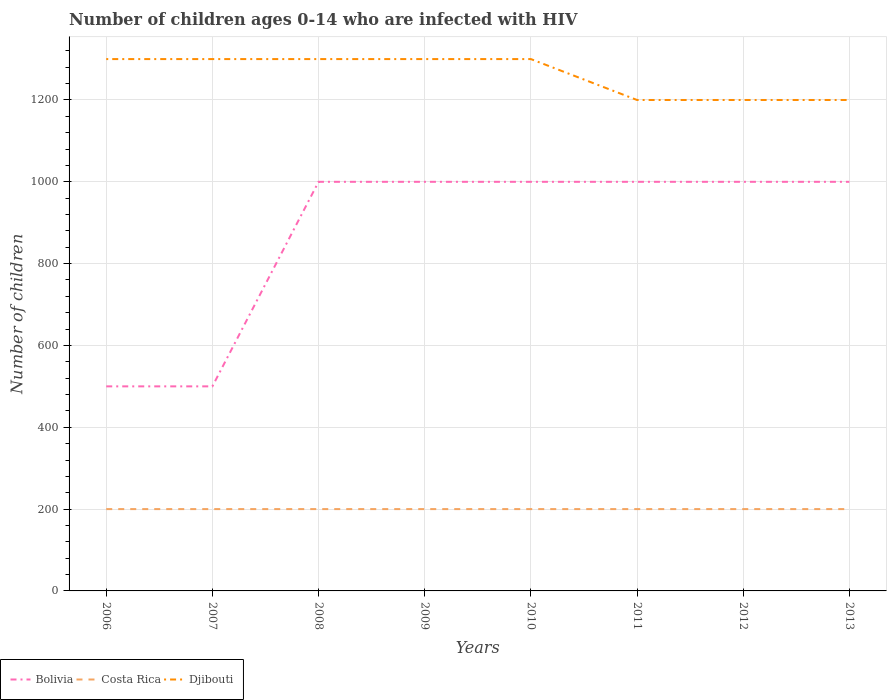How many different coloured lines are there?
Provide a short and direct response. 3. Does the line corresponding to Djibouti intersect with the line corresponding to Costa Rica?
Ensure brevity in your answer.  No. Is the number of lines equal to the number of legend labels?
Offer a very short reply. Yes. Across all years, what is the maximum number of HIV infected children in Bolivia?
Provide a succinct answer. 500. What is the total number of HIV infected children in Bolivia in the graph?
Make the answer very short. 0. Is the number of HIV infected children in Djibouti strictly greater than the number of HIV infected children in Costa Rica over the years?
Give a very brief answer. No. What is the difference between two consecutive major ticks on the Y-axis?
Make the answer very short. 200. Are the values on the major ticks of Y-axis written in scientific E-notation?
Your answer should be compact. No. Where does the legend appear in the graph?
Give a very brief answer. Bottom left. How many legend labels are there?
Your answer should be very brief. 3. What is the title of the graph?
Offer a terse response. Number of children ages 0-14 who are infected with HIV. Does "Timor-Leste" appear as one of the legend labels in the graph?
Ensure brevity in your answer.  No. What is the label or title of the X-axis?
Your answer should be very brief. Years. What is the label or title of the Y-axis?
Offer a terse response. Number of children. What is the Number of children in Bolivia in 2006?
Keep it short and to the point. 500. What is the Number of children of Costa Rica in 2006?
Ensure brevity in your answer.  200. What is the Number of children of Djibouti in 2006?
Offer a very short reply. 1300. What is the Number of children in Costa Rica in 2007?
Keep it short and to the point. 200. What is the Number of children in Djibouti in 2007?
Keep it short and to the point. 1300. What is the Number of children of Bolivia in 2008?
Make the answer very short. 1000. What is the Number of children in Costa Rica in 2008?
Provide a short and direct response. 200. What is the Number of children in Djibouti in 2008?
Provide a succinct answer. 1300. What is the Number of children of Bolivia in 2009?
Offer a very short reply. 1000. What is the Number of children of Djibouti in 2009?
Your answer should be compact. 1300. What is the Number of children of Djibouti in 2010?
Provide a succinct answer. 1300. What is the Number of children in Bolivia in 2011?
Give a very brief answer. 1000. What is the Number of children of Costa Rica in 2011?
Your answer should be very brief. 200. What is the Number of children of Djibouti in 2011?
Offer a terse response. 1200. What is the Number of children in Bolivia in 2012?
Offer a terse response. 1000. What is the Number of children in Djibouti in 2012?
Your answer should be very brief. 1200. What is the Number of children in Bolivia in 2013?
Make the answer very short. 1000. What is the Number of children in Costa Rica in 2013?
Ensure brevity in your answer.  200. What is the Number of children of Djibouti in 2013?
Offer a terse response. 1200. Across all years, what is the maximum Number of children in Bolivia?
Keep it short and to the point. 1000. Across all years, what is the maximum Number of children in Djibouti?
Offer a very short reply. 1300. Across all years, what is the minimum Number of children in Bolivia?
Provide a succinct answer. 500. Across all years, what is the minimum Number of children of Djibouti?
Provide a short and direct response. 1200. What is the total Number of children in Bolivia in the graph?
Keep it short and to the point. 7000. What is the total Number of children of Costa Rica in the graph?
Your response must be concise. 1600. What is the total Number of children of Djibouti in the graph?
Your answer should be compact. 1.01e+04. What is the difference between the Number of children in Bolivia in 2006 and that in 2008?
Keep it short and to the point. -500. What is the difference between the Number of children of Djibouti in 2006 and that in 2008?
Provide a short and direct response. 0. What is the difference between the Number of children of Bolivia in 2006 and that in 2009?
Provide a succinct answer. -500. What is the difference between the Number of children of Bolivia in 2006 and that in 2010?
Give a very brief answer. -500. What is the difference between the Number of children of Djibouti in 2006 and that in 2010?
Give a very brief answer. 0. What is the difference between the Number of children of Bolivia in 2006 and that in 2011?
Offer a very short reply. -500. What is the difference between the Number of children of Djibouti in 2006 and that in 2011?
Your answer should be compact. 100. What is the difference between the Number of children of Bolivia in 2006 and that in 2012?
Provide a succinct answer. -500. What is the difference between the Number of children of Djibouti in 2006 and that in 2012?
Offer a very short reply. 100. What is the difference between the Number of children in Bolivia in 2006 and that in 2013?
Provide a succinct answer. -500. What is the difference between the Number of children of Djibouti in 2006 and that in 2013?
Keep it short and to the point. 100. What is the difference between the Number of children in Bolivia in 2007 and that in 2008?
Make the answer very short. -500. What is the difference between the Number of children in Costa Rica in 2007 and that in 2008?
Give a very brief answer. 0. What is the difference between the Number of children in Bolivia in 2007 and that in 2009?
Offer a terse response. -500. What is the difference between the Number of children of Djibouti in 2007 and that in 2009?
Provide a short and direct response. 0. What is the difference between the Number of children of Bolivia in 2007 and that in 2010?
Your answer should be compact. -500. What is the difference between the Number of children in Costa Rica in 2007 and that in 2010?
Your response must be concise. 0. What is the difference between the Number of children of Bolivia in 2007 and that in 2011?
Give a very brief answer. -500. What is the difference between the Number of children in Bolivia in 2007 and that in 2012?
Offer a very short reply. -500. What is the difference between the Number of children of Costa Rica in 2007 and that in 2012?
Provide a succinct answer. 0. What is the difference between the Number of children in Djibouti in 2007 and that in 2012?
Give a very brief answer. 100. What is the difference between the Number of children in Bolivia in 2007 and that in 2013?
Ensure brevity in your answer.  -500. What is the difference between the Number of children in Bolivia in 2008 and that in 2009?
Give a very brief answer. 0. What is the difference between the Number of children of Costa Rica in 2008 and that in 2009?
Provide a short and direct response. 0. What is the difference between the Number of children in Djibouti in 2008 and that in 2009?
Offer a very short reply. 0. What is the difference between the Number of children in Bolivia in 2008 and that in 2010?
Provide a succinct answer. 0. What is the difference between the Number of children of Costa Rica in 2008 and that in 2010?
Offer a terse response. 0. What is the difference between the Number of children in Djibouti in 2008 and that in 2010?
Ensure brevity in your answer.  0. What is the difference between the Number of children in Bolivia in 2008 and that in 2011?
Provide a short and direct response. 0. What is the difference between the Number of children in Costa Rica in 2008 and that in 2011?
Offer a terse response. 0. What is the difference between the Number of children in Djibouti in 2008 and that in 2011?
Ensure brevity in your answer.  100. What is the difference between the Number of children in Bolivia in 2008 and that in 2012?
Your answer should be very brief. 0. What is the difference between the Number of children in Djibouti in 2008 and that in 2013?
Offer a very short reply. 100. What is the difference between the Number of children in Bolivia in 2009 and that in 2011?
Provide a succinct answer. 0. What is the difference between the Number of children of Costa Rica in 2009 and that in 2011?
Provide a succinct answer. 0. What is the difference between the Number of children in Djibouti in 2009 and that in 2011?
Make the answer very short. 100. What is the difference between the Number of children of Bolivia in 2009 and that in 2012?
Your answer should be compact. 0. What is the difference between the Number of children of Djibouti in 2009 and that in 2013?
Ensure brevity in your answer.  100. What is the difference between the Number of children of Bolivia in 2010 and that in 2011?
Give a very brief answer. 0. What is the difference between the Number of children in Costa Rica in 2010 and that in 2011?
Your answer should be compact. 0. What is the difference between the Number of children in Djibouti in 2010 and that in 2012?
Offer a terse response. 100. What is the difference between the Number of children in Bolivia in 2010 and that in 2013?
Provide a succinct answer. 0. What is the difference between the Number of children in Costa Rica in 2010 and that in 2013?
Give a very brief answer. 0. What is the difference between the Number of children in Bolivia in 2011 and that in 2012?
Ensure brevity in your answer.  0. What is the difference between the Number of children in Djibouti in 2011 and that in 2012?
Your response must be concise. 0. What is the difference between the Number of children in Bolivia in 2011 and that in 2013?
Offer a very short reply. 0. What is the difference between the Number of children of Costa Rica in 2012 and that in 2013?
Your answer should be very brief. 0. What is the difference between the Number of children in Bolivia in 2006 and the Number of children in Costa Rica in 2007?
Your answer should be compact. 300. What is the difference between the Number of children in Bolivia in 2006 and the Number of children in Djibouti in 2007?
Give a very brief answer. -800. What is the difference between the Number of children in Costa Rica in 2006 and the Number of children in Djibouti in 2007?
Provide a succinct answer. -1100. What is the difference between the Number of children in Bolivia in 2006 and the Number of children in Costa Rica in 2008?
Ensure brevity in your answer.  300. What is the difference between the Number of children in Bolivia in 2006 and the Number of children in Djibouti in 2008?
Your response must be concise. -800. What is the difference between the Number of children in Costa Rica in 2006 and the Number of children in Djibouti in 2008?
Offer a very short reply. -1100. What is the difference between the Number of children in Bolivia in 2006 and the Number of children in Costa Rica in 2009?
Your response must be concise. 300. What is the difference between the Number of children in Bolivia in 2006 and the Number of children in Djibouti in 2009?
Give a very brief answer. -800. What is the difference between the Number of children in Costa Rica in 2006 and the Number of children in Djibouti in 2009?
Make the answer very short. -1100. What is the difference between the Number of children of Bolivia in 2006 and the Number of children of Costa Rica in 2010?
Your answer should be very brief. 300. What is the difference between the Number of children in Bolivia in 2006 and the Number of children in Djibouti in 2010?
Provide a succinct answer. -800. What is the difference between the Number of children in Costa Rica in 2006 and the Number of children in Djibouti in 2010?
Your response must be concise. -1100. What is the difference between the Number of children of Bolivia in 2006 and the Number of children of Costa Rica in 2011?
Offer a very short reply. 300. What is the difference between the Number of children in Bolivia in 2006 and the Number of children in Djibouti in 2011?
Your answer should be compact. -700. What is the difference between the Number of children in Costa Rica in 2006 and the Number of children in Djibouti in 2011?
Provide a short and direct response. -1000. What is the difference between the Number of children of Bolivia in 2006 and the Number of children of Costa Rica in 2012?
Offer a very short reply. 300. What is the difference between the Number of children in Bolivia in 2006 and the Number of children in Djibouti in 2012?
Make the answer very short. -700. What is the difference between the Number of children of Costa Rica in 2006 and the Number of children of Djibouti in 2012?
Ensure brevity in your answer.  -1000. What is the difference between the Number of children of Bolivia in 2006 and the Number of children of Costa Rica in 2013?
Your answer should be very brief. 300. What is the difference between the Number of children of Bolivia in 2006 and the Number of children of Djibouti in 2013?
Provide a short and direct response. -700. What is the difference between the Number of children in Costa Rica in 2006 and the Number of children in Djibouti in 2013?
Your answer should be compact. -1000. What is the difference between the Number of children of Bolivia in 2007 and the Number of children of Costa Rica in 2008?
Offer a terse response. 300. What is the difference between the Number of children in Bolivia in 2007 and the Number of children in Djibouti in 2008?
Your response must be concise. -800. What is the difference between the Number of children in Costa Rica in 2007 and the Number of children in Djibouti in 2008?
Give a very brief answer. -1100. What is the difference between the Number of children of Bolivia in 2007 and the Number of children of Costa Rica in 2009?
Ensure brevity in your answer.  300. What is the difference between the Number of children of Bolivia in 2007 and the Number of children of Djibouti in 2009?
Offer a terse response. -800. What is the difference between the Number of children in Costa Rica in 2007 and the Number of children in Djibouti in 2009?
Your response must be concise. -1100. What is the difference between the Number of children of Bolivia in 2007 and the Number of children of Costa Rica in 2010?
Make the answer very short. 300. What is the difference between the Number of children in Bolivia in 2007 and the Number of children in Djibouti in 2010?
Provide a succinct answer. -800. What is the difference between the Number of children of Costa Rica in 2007 and the Number of children of Djibouti in 2010?
Your response must be concise. -1100. What is the difference between the Number of children of Bolivia in 2007 and the Number of children of Costa Rica in 2011?
Provide a succinct answer. 300. What is the difference between the Number of children in Bolivia in 2007 and the Number of children in Djibouti in 2011?
Provide a short and direct response. -700. What is the difference between the Number of children in Costa Rica in 2007 and the Number of children in Djibouti in 2011?
Keep it short and to the point. -1000. What is the difference between the Number of children in Bolivia in 2007 and the Number of children in Costa Rica in 2012?
Make the answer very short. 300. What is the difference between the Number of children in Bolivia in 2007 and the Number of children in Djibouti in 2012?
Keep it short and to the point. -700. What is the difference between the Number of children in Costa Rica in 2007 and the Number of children in Djibouti in 2012?
Offer a very short reply. -1000. What is the difference between the Number of children of Bolivia in 2007 and the Number of children of Costa Rica in 2013?
Provide a succinct answer. 300. What is the difference between the Number of children in Bolivia in 2007 and the Number of children in Djibouti in 2013?
Make the answer very short. -700. What is the difference between the Number of children in Costa Rica in 2007 and the Number of children in Djibouti in 2013?
Offer a very short reply. -1000. What is the difference between the Number of children in Bolivia in 2008 and the Number of children in Costa Rica in 2009?
Keep it short and to the point. 800. What is the difference between the Number of children of Bolivia in 2008 and the Number of children of Djibouti in 2009?
Your answer should be very brief. -300. What is the difference between the Number of children of Costa Rica in 2008 and the Number of children of Djibouti in 2009?
Offer a very short reply. -1100. What is the difference between the Number of children of Bolivia in 2008 and the Number of children of Costa Rica in 2010?
Your answer should be very brief. 800. What is the difference between the Number of children in Bolivia in 2008 and the Number of children in Djibouti in 2010?
Ensure brevity in your answer.  -300. What is the difference between the Number of children of Costa Rica in 2008 and the Number of children of Djibouti in 2010?
Ensure brevity in your answer.  -1100. What is the difference between the Number of children of Bolivia in 2008 and the Number of children of Costa Rica in 2011?
Provide a short and direct response. 800. What is the difference between the Number of children in Bolivia in 2008 and the Number of children in Djibouti in 2011?
Offer a very short reply. -200. What is the difference between the Number of children of Costa Rica in 2008 and the Number of children of Djibouti in 2011?
Give a very brief answer. -1000. What is the difference between the Number of children of Bolivia in 2008 and the Number of children of Costa Rica in 2012?
Make the answer very short. 800. What is the difference between the Number of children in Bolivia in 2008 and the Number of children in Djibouti in 2012?
Keep it short and to the point. -200. What is the difference between the Number of children in Costa Rica in 2008 and the Number of children in Djibouti in 2012?
Ensure brevity in your answer.  -1000. What is the difference between the Number of children in Bolivia in 2008 and the Number of children in Costa Rica in 2013?
Offer a terse response. 800. What is the difference between the Number of children in Bolivia in 2008 and the Number of children in Djibouti in 2013?
Ensure brevity in your answer.  -200. What is the difference between the Number of children in Costa Rica in 2008 and the Number of children in Djibouti in 2013?
Your answer should be compact. -1000. What is the difference between the Number of children of Bolivia in 2009 and the Number of children of Costa Rica in 2010?
Offer a terse response. 800. What is the difference between the Number of children in Bolivia in 2009 and the Number of children in Djibouti in 2010?
Your answer should be very brief. -300. What is the difference between the Number of children of Costa Rica in 2009 and the Number of children of Djibouti in 2010?
Make the answer very short. -1100. What is the difference between the Number of children in Bolivia in 2009 and the Number of children in Costa Rica in 2011?
Provide a succinct answer. 800. What is the difference between the Number of children of Bolivia in 2009 and the Number of children of Djibouti in 2011?
Provide a succinct answer. -200. What is the difference between the Number of children in Costa Rica in 2009 and the Number of children in Djibouti in 2011?
Your response must be concise. -1000. What is the difference between the Number of children in Bolivia in 2009 and the Number of children in Costa Rica in 2012?
Make the answer very short. 800. What is the difference between the Number of children of Bolivia in 2009 and the Number of children of Djibouti in 2012?
Ensure brevity in your answer.  -200. What is the difference between the Number of children of Costa Rica in 2009 and the Number of children of Djibouti in 2012?
Give a very brief answer. -1000. What is the difference between the Number of children of Bolivia in 2009 and the Number of children of Costa Rica in 2013?
Offer a very short reply. 800. What is the difference between the Number of children of Bolivia in 2009 and the Number of children of Djibouti in 2013?
Ensure brevity in your answer.  -200. What is the difference between the Number of children of Costa Rica in 2009 and the Number of children of Djibouti in 2013?
Provide a succinct answer. -1000. What is the difference between the Number of children of Bolivia in 2010 and the Number of children of Costa Rica in 2011?
Make the answer very short. 800. What is the difference between the Number of children of Bolivia in 2010 and the Number of children of Djibouti in 2011?
Provide a short and direct response. -200. What is the difference between the Number of children in Costa Rica in 2010 and the Number of children in Djibouti in 2011?
Provide a succinct answer. -1000. What is the difference between the Number of children in Bolivia in 2010 and the Number of children in Costa Rica in 2012?
Provide a short and direct response. 800. What is the difference between the Number of children in Bolivia in 2010 and the Number of children in Djibouti in 2012?
Provide a short and direct response. -200. What is the difference between the Number of children of Costa Rica in 2010 and the Number of children of Djibouti in 2012?
Make the answer very short. -1000. What is the difference between the Number of children of Bolivia in 2010 and the Number of children of Costa Rica in 2013?
Provide a short and direct response. 800. What is the difference between the Number of children in Bolivia in 2010 and the Number of children in Djibouti in 2013?
Ensure brevity in your answer.  -200. What is the difference between the Number of children in Costa Rica in 2010 and the Number of children in Djibouti in 2013?
Your answer should be very brief. -1000. What is the difference between the Number of children of Bolivia in 2011 and the Number of children of Costa Rica in 2012?
Ensure brevity in your answer.  800. What is the difference between the Number of children in Bolivia in 2011 and the Number of children in Djibouti in 2012?
Offer a terse response. -200. What is the difference between the Number of children of Costa Rica in 2011 and the Number of children of Djibouti in 2012?
Offer a very short reply. -1000. What is the difference between the Number of children in Bolivia in 2011 and the Number of children in Costa Rica in 2013?
Provide a short and direct response. 800. What is the difference between the Number of children of Bolivia in 2011 and the Number of children of Djibouti in 2013?
Offer a very short reply. -200. What is the difference between the Number of children of Costa Rica in 2011 and the Number of children of Djibouti in 2013?
Offer a terse response. -1000. What is the difference between the Number of children in Bolivia in 2012 and the Number of children in Costa Rica in 2013?
Offer a terse response. 800. What is the difference between the Number of children of Bolivia in 2012 and the Number of children of Djibouti in 2013?
Give a very brief answer. -200. What is the difference between the Number of children of Costa Rica in 2012 and the Number of children of Djibouti in 2013?
Your answer should be very brief. -1000. What is the average Number of children in Bolivia per year?
Give a very brief answer. 875. What is the average Number of children of Djibouti per year?
Ensure brevity in your answer.  1262.5. In the year 2006, what is the difference between the Number of children in Bolivia and Number of children in Costa Rica?
Provide a short and direct response. 300. In the year 2006, what is the difference between the Number of children in Bolivia and Number of children in Djibouti?
Your answer should be compact. -800. In the year 2006, what is the difference between the Number of children in Costa Rica and Number of children in Djibouti?
Give a very brief answer. -1100. In the year 2007, what is the difference between the Number of children of Bolivia and Number of children of Costa Rica?
Make the answer very short. 300. In the year 2007, what is the difference between the Number of children in Bolivia and Number of children in Djibouti?
Offer a very short reply. -800. In the year 2007, what is the difference between the Number of children of Costa Rica and Number of children of Djibouti?
Give a very brief answer. -1100. In the year 2008, what is the difference between the Number of children in Bolivia and Number of children in Costa Rica?
Offer a very short reply. 800. In the year 2008, what is the difference between the Number of children in Bolivia and Number of children in Djibouti?
Your answer should be compact. -300. In the year 2008, what is the difference between the Number of children of Costa Rica and Number of children of Djibouti?
Offer a terse response. -1100. In the year 2009, what is the difference between the Number of children of Bolivia and Number of children of Costa Rica?
Provide a short and direct response. 800. In the year 2009, what is the difference between the Number of children of Bolivia and Number of children of Djibouti?
Your response must be concise. -300. In the year 2009, what is the difference between the Number of children of Costa Rica and Number of children of Djibouti?
Your response must be concise. -1100. In the year 2010, what is the difference between the Number of children of Bolivia and Number of children of Costa Rica?
Offer a terse response. 800. In the year 2010, what is the difference between the Number of children in Bolivia and Number of children in Djibouti?
Your answer should be very brief. -300. In the year 2010, what is the difference between the Number of children in Costa Rica and Number of children in Djibouti?
Offer a very short reply. -1100. In the year 2011, what is the difference between the Number of children of Bolivia and Number of children of Costa Rica?
Keep it short and to the point. 800. In the year 2011, what is the difference between the Number of children of Bolivia and Number of children of Djibouti?
Give a very brief answer. -200. In the year 2011, what is the difference between the Number of children of Costa Rica and Number of children of Djibouti?
Give a very brief answer. -1000. In the year 2012, what is the difference between the Number of children of Bolivia and Number of children of Costa Rica?
Give a very brief answer. 800. In the year 2012, what is the difference between the Number of children of Bolivia and Number of children of Djibouti?
Make the answer very short. -200. In the year 2012, what is the difference between the Number of children in Costa Rica and Number of children in Djibouti?
Provide a short and direct response. -1000. In the year 2013, what is the difference between the Number of children of Bolivia and Number of children of Costa Rica?
Provide a succinct answer. 800. In the year 2013, what is the difference between the Number of children in Bolivia and Number of children in Djibouti?
Make the answer very short. -200. In the year 2013, what is the difference between the Number of children of Costa Rica and Number of children of Djibouti?
Keep it short and to the point. -1000. What is the ratio of the Number of children in Bolivia in 2006 to that in 2007?
Provide a succinct answer. 1. What is the ratio of the Number of children in Costa Rica in 2006 to that in 2008?
Offer a very short reply. 1. What is the ratio of the Number of children of Djibouti in 2006 to that in 2008?
Offer a terse response. 1. What is the ratio of the Number of children in Bolivia in 2006 to that in 2009?
Keep it short and to the point. 0.5. What is the ratio of the Number of children of Costa Rica in 2006 to that in 2010?
Your answer should be compact. 1. What is the ratio of the Number of children in Bolivia in 2006 to that in 2011?
Ensure brevity in your answer.  0.5. What is the ratio of the Number of children of Djibouti in 2006 to that in 2011?
Offer a very short reply. 1.08. What is the ratio of the Number of children of Costa Rica in 2006 to that in 2013?
Offer a terse response. 1. What is the ratio of the Number of children of Bolivia in 2007 to that in 2008?
Provide a short and direct response. 0.5. What is the ratio of the Number of children of Costa Rica in 2007 to that in 2008?
Offer a very short reply. 1. What is the ratio of the Number of children of Djibouti in 2007 to that in 2008?
Keep it short and to the point. 1. What is the ratio of the Number of children of Bolivia in 2007 to that in 2009?
Keep it short and to the point. 0.5. What is the ratio of the Number of children in Djibouti in 2007 to that in 2009?
Your answer should be very brief. 1. What is the ratio of the Number of children in Bolivia in 2007 to that in 2010?
Provide a short and direct response. 0.5. What is the ratio of the Number of children of Costa Rica in 2007 to that in 2011?
Ensure brevity in your answer.  1. What is the ratio of the Number of children of Bolivia in 2007 to that in 2012?
Your answer should be compact. 0.5. What is the ratio of the Number of children of Djibouti in 2007 to that in 2012?
Your answer should be compact. 1.08. What is the ratio of the Number of children in Costa Rica in 2007 to that in 2013?
Provide a short and direct response. 1. What is the ratio of the Number of children in Djibouti in 2007 to that in 2013?
Offer a terse response. 1.08. What is the ratio of the Number of children in Costa Rica in 2008 to that in 2009?
Ensure brevity in your answer.  1. What is the ratio of the Number of children in Bolivia in 2008 to that in 2010?
Provide a short and direct response. 1. What is the ratio of the Number of children in Costa Rica in 2008 to that in 2010?
Offer a terse response. 1. What is the ratio of the Number of children in Djibouti in 2008 to that in 2010?
Provide a short and direct response. 1. What is the ratio of the Number of children in Costa Rica in 2008 to that in 2011?
Offer a terse response. 1. What is the ratio of the Number of children in Bolivia in 2009 to that in 2010?
Offer a terse response. 1. What is the ratio of the Number of children in Costa Rica in 2009 to that in 2010?
Your answer should be compact. 1. What is the ratio of the Number of children of Djibouti in 2009 to that in 2010?
Keep it short and to the point. 1. What is the ratio of the Number of children in Djibouti in 2009 to that in 2011?
Offer a very short reply. 1.08. What is the ratio of the Number of children in Costa Rica in 2009 to that in 2013?
Make the answer very short. 1. What is the ratio of the Number of children in Djibouti in 2009 to that in 2013?
Give a very brief answer. 1.08. What is the ratio of the Number of children of Costa Rica in 2010 to that in 2011?
Offer a very short reply. 1. What is the ratio of the Number of children of Bolivia in 2010 to that in 2013?
Provide a succinct answer. 1. What is the ratio of the Number of children of Costa Rica in 2011 to that in 2012?
Keep it short and to the point. 1. What is the ratio of the Number of children of Djibouti in 2011 to that in 2012?
Offer a very short reply. 1. What is the ratio of the Number of children in Bolivia in 2011 to that in 2013?
Offer a very short reply. 1. What is the ratio of the Number of children of Djibouti in 2011 to that in 2013?
Offer a terse response. 1. What is the ratio of the Number of children of Costa Rica in 2012 to that in 2013?
Ensure brevity in your answer.  1. What is the difference between the highest and the second highest Number of children in Bolivia?
Provide a short and direct response. 0. What is the difference between the highest and the second highest Number of children in Costa Rica?
Ensure brevity in your answer.  0. What is the difference between the highest and the lowest Number of children in Bolivia?
Your response must be concise. 500. What is the difference between the highest and the lowest Number of children of Costa Rica?
Your answer should be very brief. 0. 